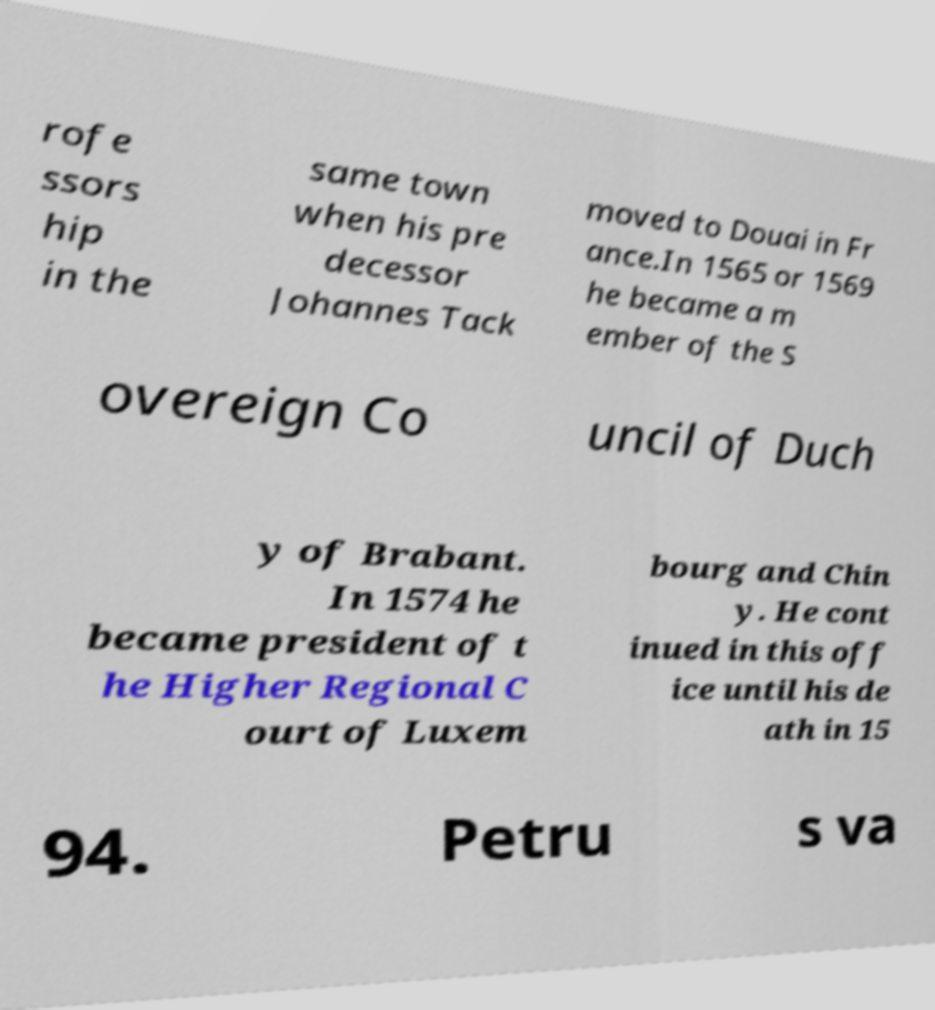Can you accurately transcribe the text from the provided image for me? rofe ssors hip in the same town when his pre decessor Johannes Tack moved to Douai in Fr ance.In 1565 or 1569 he became a m ember of the S overeign Co uncil of Duch y of Brabant. In 1574 he became president of t he Higher Regional C ourt of Luxem bourg and Chin y. He cont inued in this off ice until his de ath in 15 94. Petru s va 